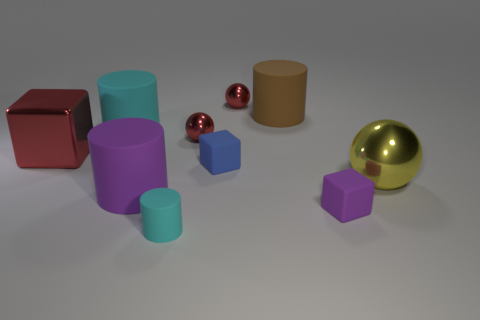Subtract all red metal spheres. How many spheres are left? 1 Subtract 3 spheres. How many spheres are left? 0 Subtract all cylinders. How many objects are left? 6 Subtract 1 red cubes. How many objects are left? 9 Subtract all red cylinders. Subtract all purple cubes. How many cylinders are left? 4 Subtract all cyan balls. How many cyan cylinders are left? 2 Subtract all objects. Subtract all big gray balls. How many objects are left? 0 Add 1 cyan rubber things. How many cyan rubber things are left? 3 Add 8 yellow balls. How many yellow balls exist? 9 Subtract all blue cubes. How many cubes are left? 2 